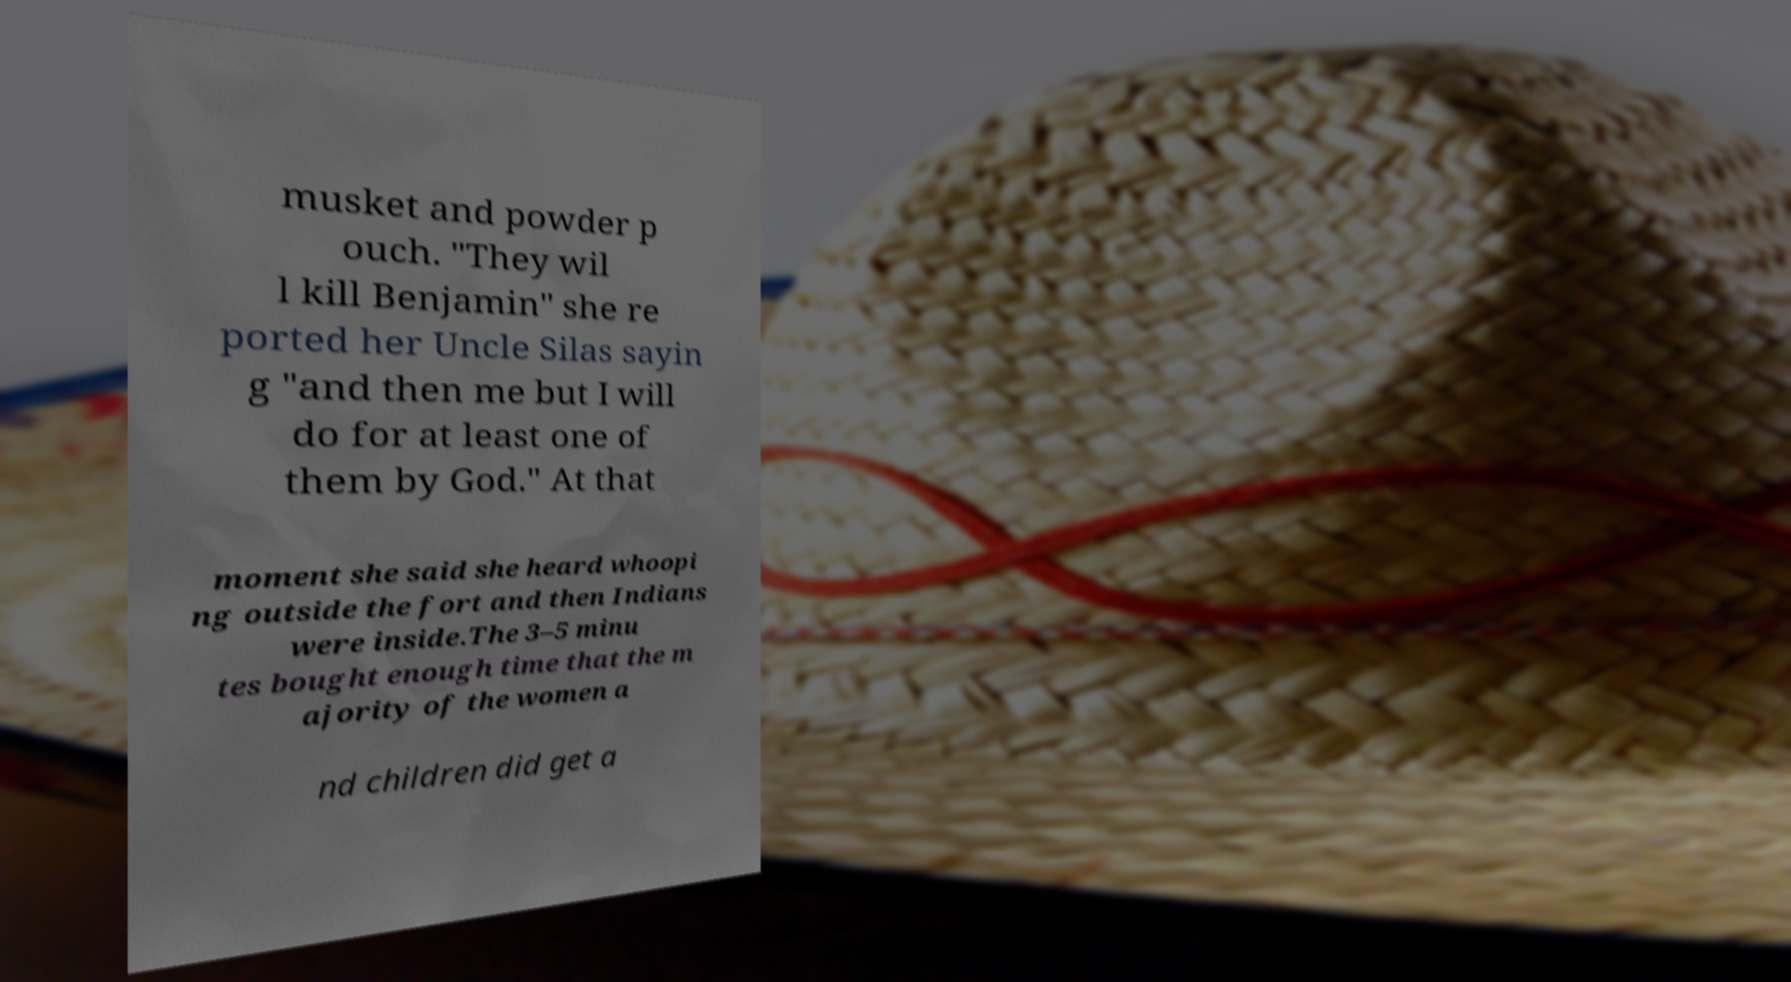I need the written content from this picture converted into text. Can you do that? musket and powder p ouch. "They wil l kill Benjamin" she re ported her Uncle Silas sayin g "and then me but I will do for at least one of them by God." At that moment she said she heard whoopi ng outside the fort and then Indians were inside.The 3–5 minu tes bought enough time that the m ajority of the women a nd children did get a 